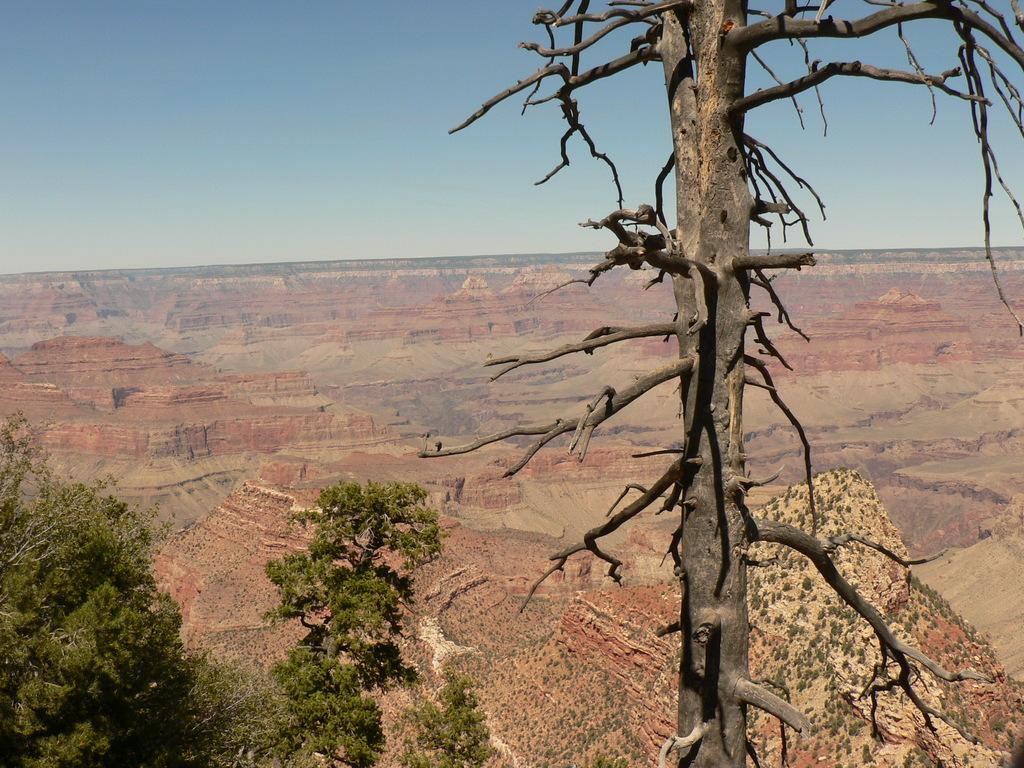What is the main subject in the foreground of the image? There is a tree trunk in the foreground of the image. What else can be seen behind the tree trunk? There is a group of trees visible behind the tree trunk. What type of landscape feature is visible in the background of the image? There are mountains visible in the background of the image. What is visible at the top of the image? The sky is visible at the top of the image. Where is the door located in the image? There is no door present in the image; it features a tree trunk, a group of trees, mountains, and the sky. 